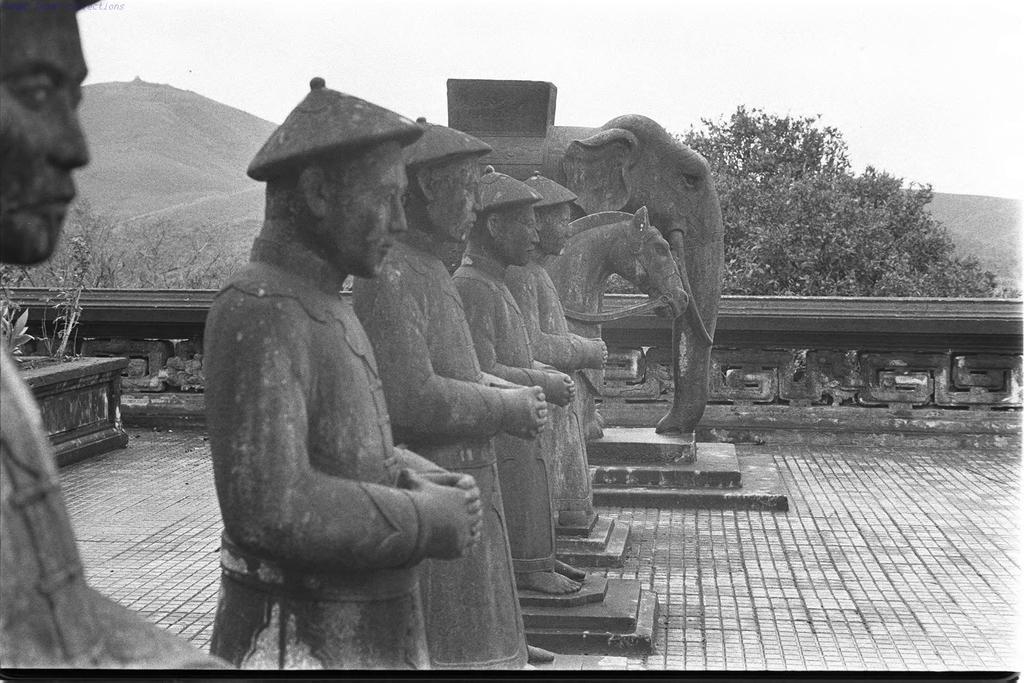Describe this image in one or two sentences. It is an old image, there are few sculptures of people and a sculpture of horse and an elephant, behind the sculptures there are trees and mountains. 